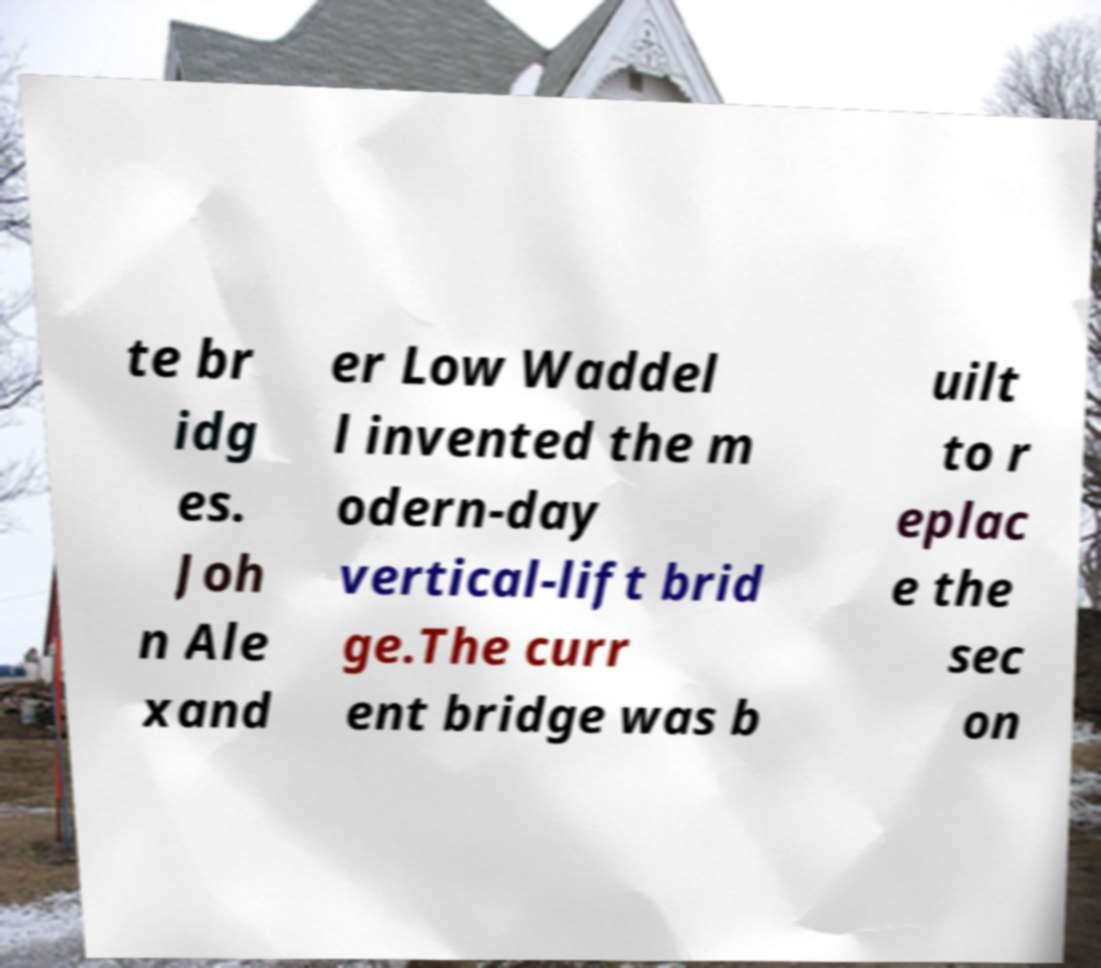Please read and relay the text visible in this image. What does it say? te br idg es. Joh n Ale xand er Low Waddel l invented the m odern-day vertical-lift brid ge.The curr ent bridge was b uilt to r eplac e the sec on 